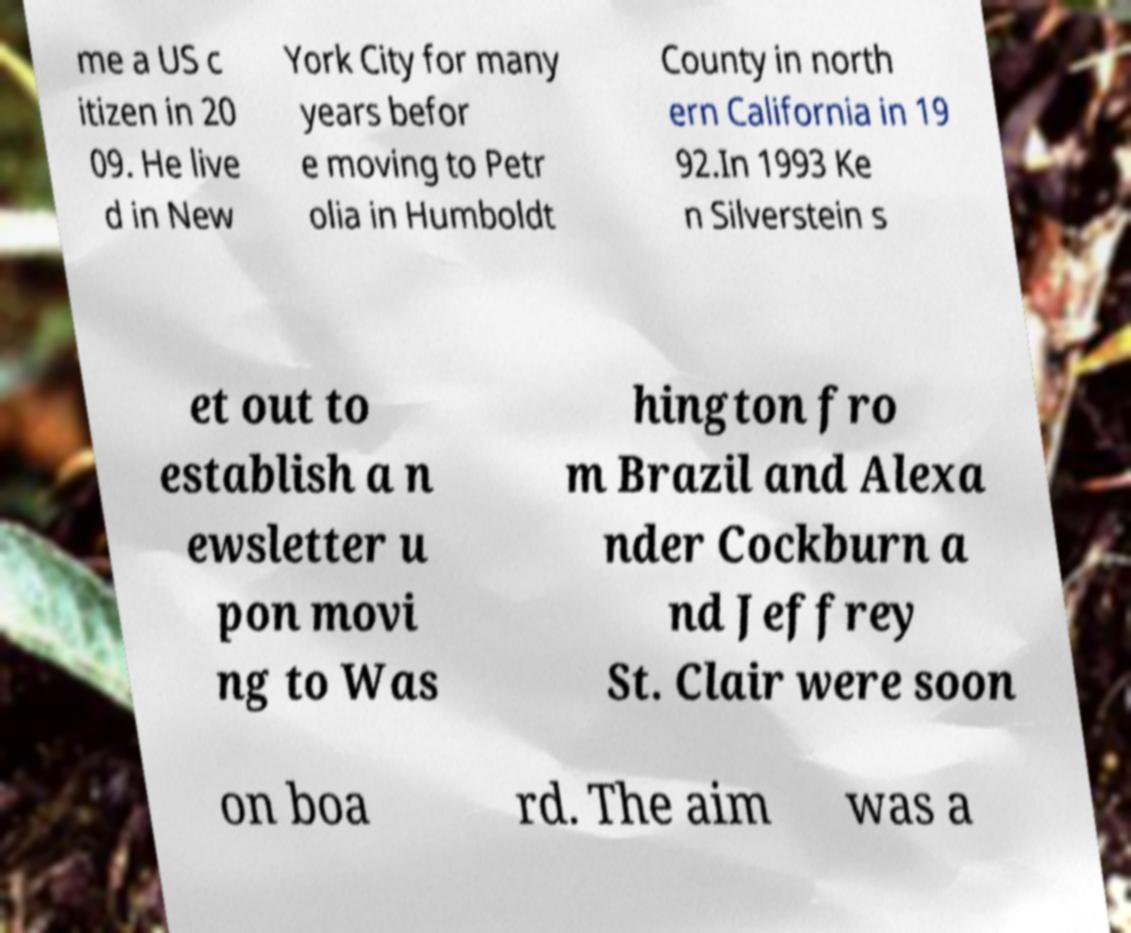There's text embedded in this image that I need extracted. Can you transcribe it verbatim? me a US c itizen in 20 09. He live d in New York City for many years befor e moving to Petr olia in Humboldt County in north ern California in 19 92.In 1993 Ke n Silverstein s et out to establish a n ewsletter u pon movi ng to Was hington fro m Brazil and Alexa nder Cockburn a nd Jeffrey St. Clair were soon on boa rd. The aim was a 